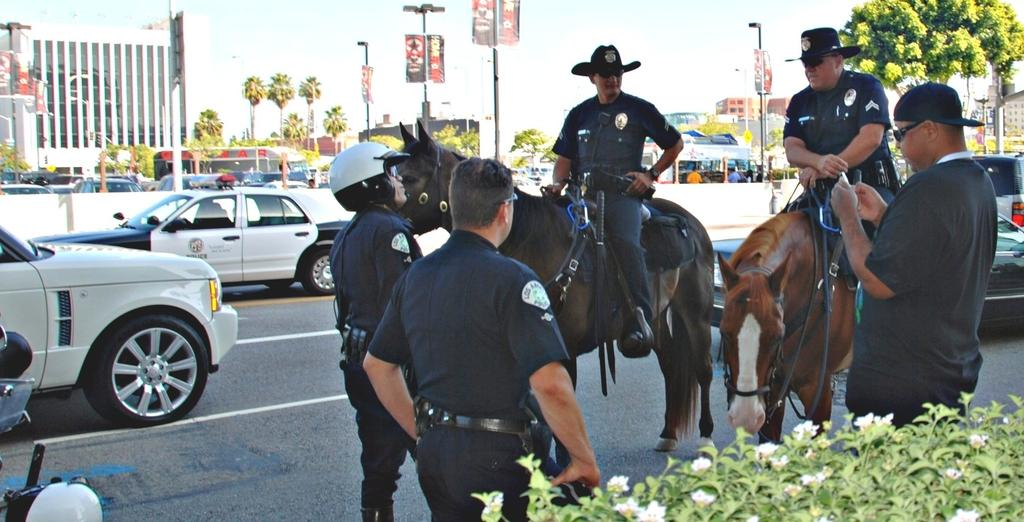How many people are standing on the road in the image? There are 3 people standing on the road in the image. How are the other people in the image positioned? There are 2 people sitting on a horse in the image. What can be seen in the background of the image? There are trees, buildings, and poles visible in the background of the image. Are there any vehicles in the image? Yes, there are cars visible in the image. Can you tell me how many spots are on the quince in the image? There is no quince or spots present in the image. What type of creature is sitting on the horse with the 2 people? There is no creature sitting on the horse with the 2 people; it is a horse. 